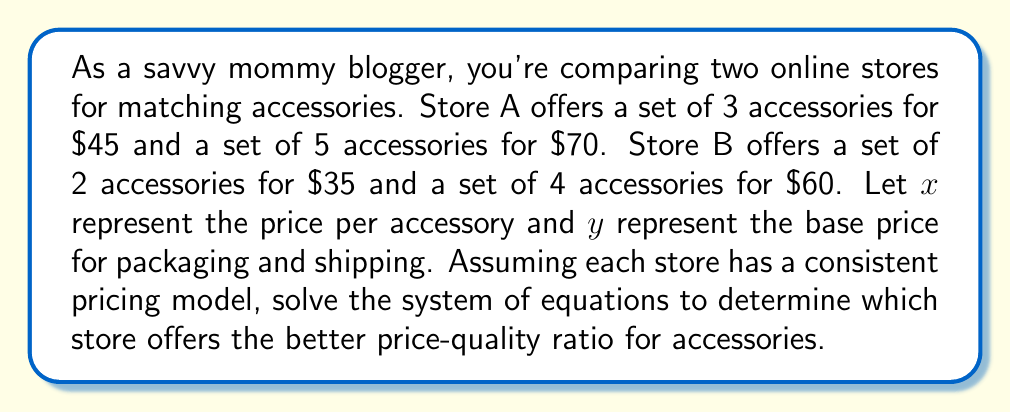Solve this math problem. Let's approach this step-by-step:

1) First, we need to set up a system of equations for each store:

   Store A:
   $$3x + y = 45$$
   $$5x + y = 70$$

   Store B:
   $$2x + y = 35$$
   $$4x + y = 60$$

2) Let's solve for Store A first:
   Subtracting the first equation from the second:
   $$2x = 25$$
   $$x = 12.50$$

   Substituting this back into the first equation:
   $$3(12.50) + y = 45$$
   $$37.50 + y = 45$$
   $$y = 7.50$$

3) Now for Store B:
   Subtracting the first equation from the second:
   $$2x = 25$$
   $$x = 12.50$$

   Substituting this back into the first equation:
   $$2(12.50) + y = 35$$
   $$25 + y = 35$$
   $$y = 10$$

4) We can now compare:
   Store A: $x = 12.50, y = 7.50
   Store B: $x = 12.50, y = 10

5) Both stores charge the same price per accessory ($12.50), but Store A has a lower base price for packaging and shipping ($7.50 vs $10).

6) To calculate the price-quality ratio, we'll use the price for a set of 3 accessories (as this is possible to buy from both stores):
   Store A: $3(12.50) + 7.50 = 45
   Store B: $3(12.50) + 10 = 47.50

Therefore, Store A offers a better price-quality ratio for accessories.
Answer: Store A, with a price of $45 for 3 accessories compared to Store B's $47.50. 